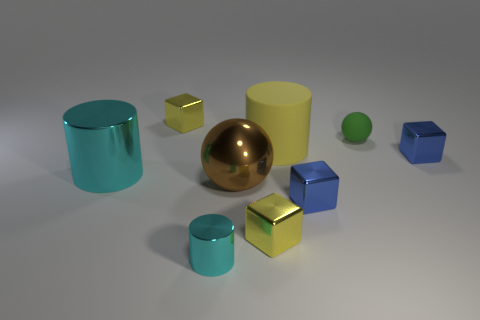There is a thing that is the same color as the large shiny cylinder; what is its material?
Provide a succinct answer. Metal. The brown shiny thing that is the same size as the yellow matte cylinder is what shape?
Provide a short and direct response. Sphere. Is there a big rubber object that has the same shape as the big brown metal thing?
Make the answer very short. No. There is a shiny cube that is behind the green sphere; is it the same size as the rubber cylinder?
Provide a succinct answer. No. How big is the block that is both behind the brown object and in front of the tiny green sphere?
Provide a succinct answer. Small. What number of other objects are the same material as the large cyan cylinder?
Provide a short and direct response. 6. What is the size of the yellow object that is behind the large yellow cylinder?
Provide a short and direct response. Small. Is the big shiny cylinder the same color as the matte sphere?
Offer a very short reply. No. What number of big objects are either yellow matte things or green balls?
Offer a very short reply. 1. Is there any other thing that has the same color as the big sphere?
Give a very brief answer. No. 